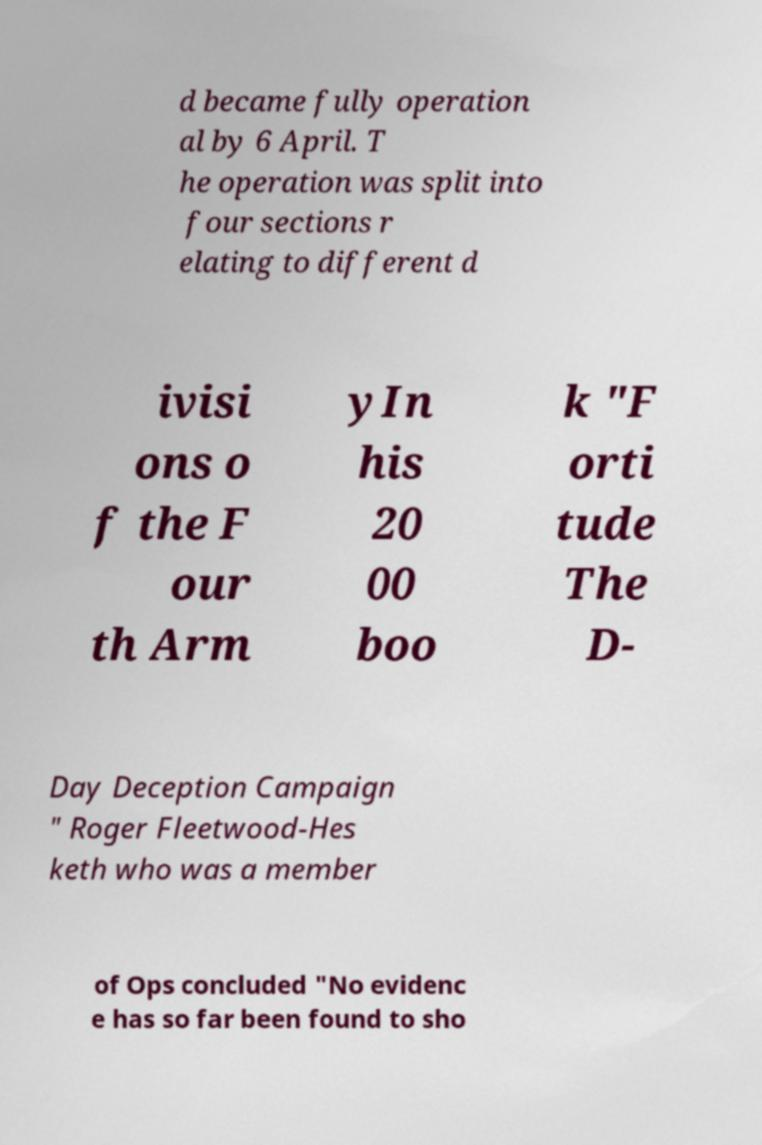Can you accurately transcribe the text from the provided image for me? d became fully operation al by 6 April. T he operation was split into four sections r elating to different d ivisi ons o f the F our th Arm yIn his 20 00 boo k "F orti tude The D- Day Deception Campaign " Roger Fleetwood-Hes keth who was a member of Ops concluded "No evidenc e has so far been found to sho 